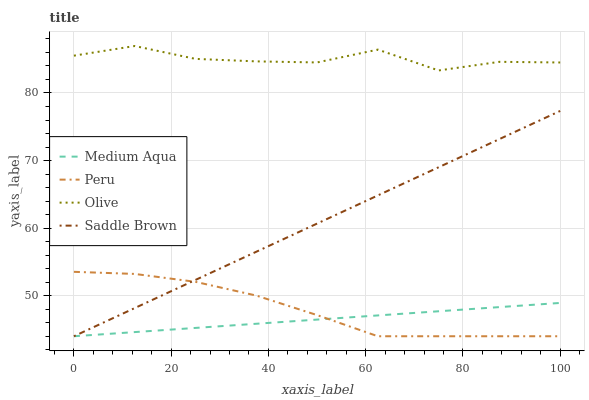Does Medium Aqua have the minimum area under the curve?
Answer yes or no. Yes. Does Olive have the maximum area under the curve?
Answer yes or no. Yes. Does Saddle Brown have the minimum area under the curve?
Answer yes or no. No. Does Saddle Brown have the maximum area under the curve?
Answer yes or no. No. Is Medium Aqua the smoothest?
Answer yes or no. Yes. Is Olive the roughest?
Answer yes or no. Yes. Is Saddle Brown the smoothest?
Answer yes or no. No. Is Saddle Brown the roughest?
Answer yes or no. No. Does Medium Aqua have the lowest value?
Answer yes or no. Yes. Does Olive have the highest value?
Answer yes or no. Yes. Does Saddle Brown have the highest value?
Answer yes or no. No. Is Peru less than Olive?
Answer yes or no. Yes. Is Olive greater than Medium Aqua?
Answer yes or no. Yes. Does Saddle Brown intersect Peru?
Answer yes or no. Yes. Is Saddle Brown less than Peru?
Answer yes or no. No. Is Saddle Brown greater than Peru?
Answer yes or no. No. Does Peru intersect Olive?
Answer yes or no. No. 